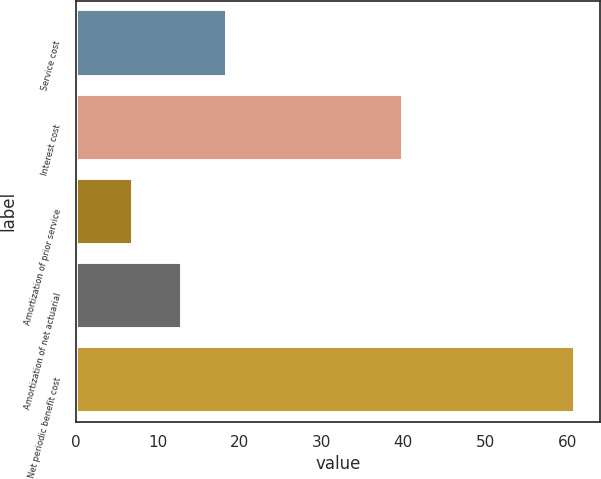Convert chart. <chart><loc_0><loc_0><loc_500><loc_500><bar_chart><fcel>Service cost<fcel>Interest cost<fcel>Amortization of prior service<fcel>Amortization of net actuarial<fcel>Net periodic benefit cost<nl><fcel>18.4<fcel>40<fcel>7<fcel>13<fcel>61<nl></chart> 